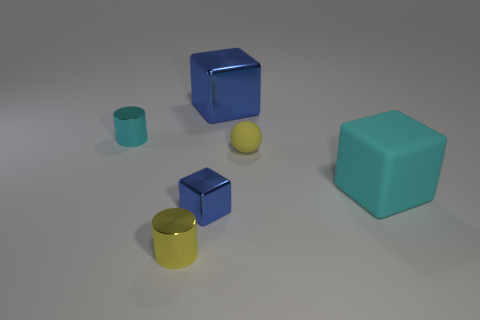Add 2 large metallic objects. How many objects exist? 8 Subtract 0 red balls. How many objects are left? 6 Subtract all cylinders. How many objects are left? 4 Subtract 3 blocks. How many blocks are left? 0 Subtract all green balls. Subtract all gray cubes. How many balls are left? 1 Subtract all purple balls. How many brown cubes are left? 0 Subtract all small purple matte cylinders. Subtract all large blue things. How many objects are left? 5 Add 3 cyan rubber cubes. How many cyan rubber cubes are left? 4 Add 1 large shiny blocks. How many large shiny blocks exist? 2 Subtract all yellow cylinders. How many cylinders are left? 1 